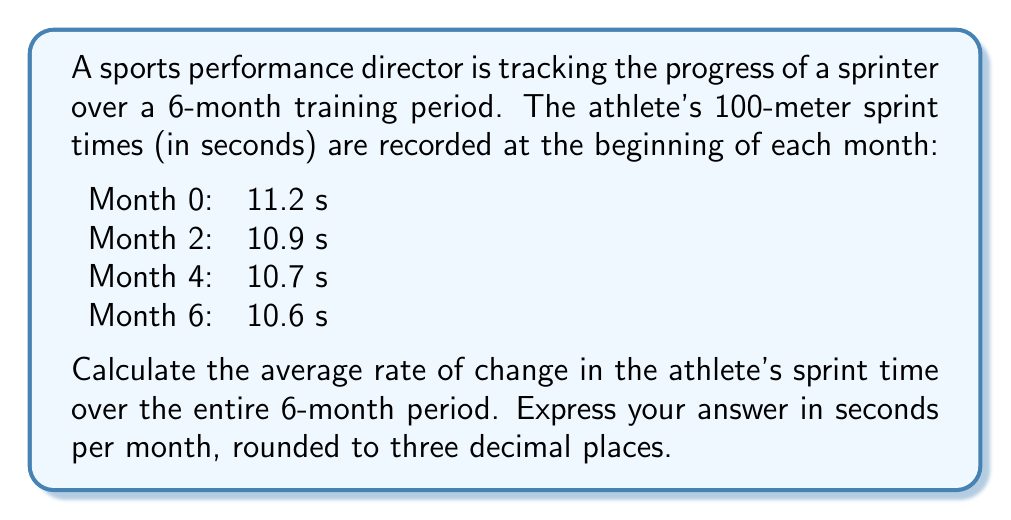Show me your answer to this math problem. To calculate the average rate of change, we need to use the formula:

$$ \text{Average rate of change} = \frac{\text{Change in y}}{\text{Change in x}} = \frac{\Delta y}{\Delta x} $$

In this case:
- $\Delta y$ is the change in sprint time (in seconds)
- $\Delta x$ is the change in time (in months)

Let's identify our initial and final values:
- Initial time (Month 0): 11.2 s
- Final time (Month 6): 10.6 s
- Total time period: 6 months

Now, let's calculate:

$$ \text{Average rate of change} = \frac{10.6 - 11.2}{6 - 0} = \frac{-0.6}{6} = -0.1 \text{ s/month} $$

The negative value indicates that the sprint time is decreasing (improving) over time.

To round to three decimal places, we don't need to make any changes as the result is already expressed to one decimal place.
Answer: -0.100 seconds per month 